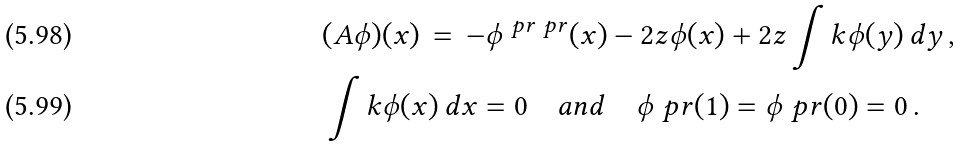<formula> <loc_0><loc_0><loc_500><loc_500>& ( A \phi ) ( x ) \, = \, - \phi ^ { \ p r \ p r } ( x ) - 2 z \phi ( x ) + 2 z \int k \phi ( y ) \, d y \, , \\ & \int k \phi ( x ) \, d x = 0 \quad a n d \quad \phi ^ { \ } p r ( 1 ) = \phi ^ { \ } p r ( 0 ) = 0 \, .</formula> 